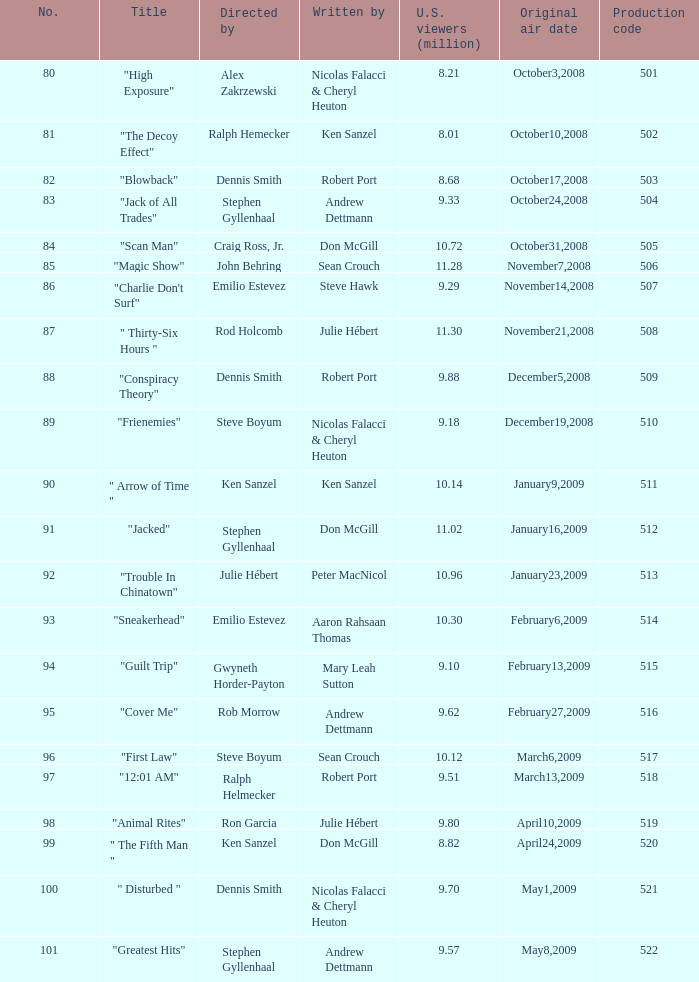How many times did episode 6 originally air? 1.0. 